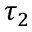<formula> <loc_0><loc_0><loc_500><loc_500>\tau _ { 2 }</formula> 